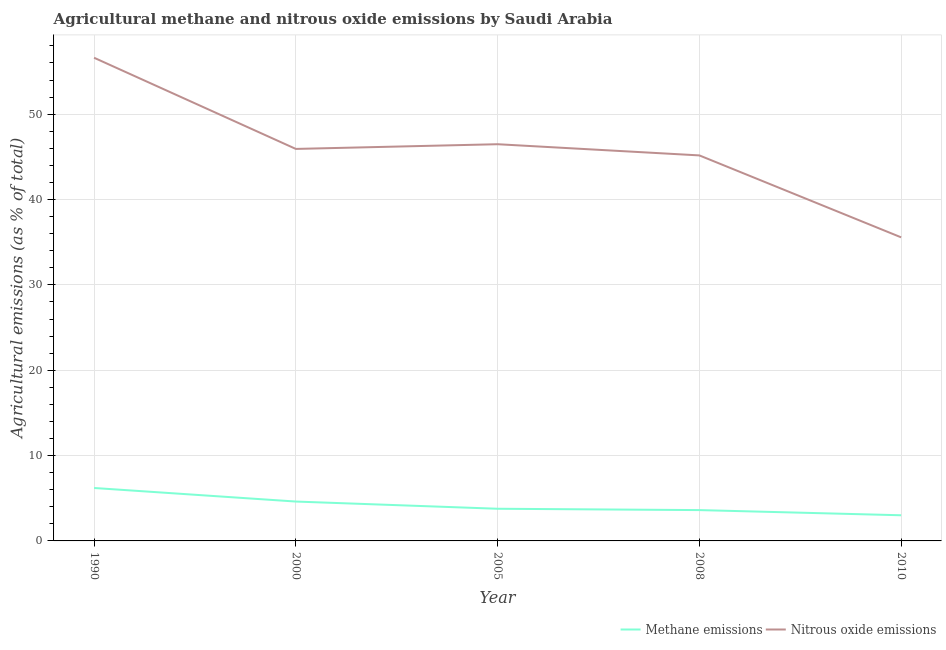What is the amount of nitrous oxide emissions in 2000?
Make the answer very short. 45.93. Across all years, what is the maximum amount of methane emissions?
Offer a terse response. 6.2. Across all years, what is the minimum amount of nitrous oxide emissions?
Give a very brief answer. 35.57. In which year was the amount of methane emissions maximum?
Provide a succinct answer. 1990. What is the total amount of nitrous oxide emissions in the graph?
Offer a very short reply. 229.76. What is the difference between the amount of nitrous oxide emissions in 2005 and that in 2010?
Your answer should be compact. 10.91. What is the difference between the amount of nitrous oxide emissions in 2008 and the amount of methane emissions in 2005?
Ensure brevity in your answer.  41.4. What is the average amount of nitrous oxide emissions per year?
Offer a terse response. 45.95. In the year 2005, what is the difference between the amount of nitrous oxide emissions and amount of methane emissions?
Provide a short and direct response. 42.71. What is the ratio of the amount of nitrous oxide emissions in 1990 to that in 2005?
Ensure brevity in your answer.  1.22. Is the difference between the amount of methane emissions in 2000 and 2008 greater than the difference between the amount of nitrous oxide emissions in 2000 and 2008?
Keep it short and to the point. Yes. What is the difference between the highest and the second highest amount of methane emissions?
Your answer should be very brief. 1.59. What is the difference between the highest and the lowest amount of methane emissions?
Your answer should be very brief. 3.2. Is the amount of nitrous oxide emissions strictly greater than the amount of methane emissions over the years?
Your answer should be very brief. Yes. Does the graph contain any zero values?
Ensure brevity in your answer.  No. Where does the legend appear in the graph?
Offer a very short reply. Bottom right. How many legend labels are there?
Provide a succinct answer. 2. What is the title of the graph?
Give a very brief answer. Agricultural methane and nitrous oxide emissions by Saudi Arabia. What is the label or title of the X-axis?
Your answer should be very brief. Year. What is the label or title of the Y-axis?
Offer a very short reply. Agricultural emissions (as % of total). What is the Agricultural emissions (as % of total) of Methane emissions in 1990?
Give a very brief answer. 6.2. What is the Agricultural emissions (as % of total) of Nitrous oxide emissions in 1990?
Your answer should be very brief. 56.61. What is the Agricultural emissions (as % of total) of Methane emissions in 2000?
Your answer should be very brief. 4.61. What is the Agricultural emissions (as % of total) in Nitrous oxide emissions in 2000?
Ensure brevity in your answer.  45.93. What is the Agricultural emissions (as % of total) in Methane emissions in 2005?
Your response must be concise. 3.77. What is the Agricultural emissions (as % of total) in Nitrous oxide emissions in 2005?
Your answer should be very brief. 46.48. What is the Agricultural emissions (as % of total) of Methane emissions in 2008?
Give a very brief answer. 3.61. What is the Agricultural emissions (as % of total) of Nitrous oxide emissions in 2008?
Give a very brief answer. 45.17. What is the Agricultural emissions (as % of total) in Methane emissions in 2010?
Make the answer very short. 3.01. What is the Agricultural emissions (as % of total) of Nitrous oxide emissions in 2010?
Your answer should be compact. 35.57. Across all years, what is the maximum Agricultural emissions (as % of total) of Methane emissions?
Your response must be concise. 6.2. Across all years, what is the maximum Agricultural emissions (as % of total) in Nitrous oxide emissions?
Your answer should be compact. 56.61. Across all years, what is the minimum Agricultural emissions (as % of total) of Methane emissions?
Offer a very short reply. 3.01. Across all years, what is the minimum Agricultural emissions (as % of total) of Nitrous oxide emissions?
Provide a succinct answer. 35.57. What is the total Agricultural emissions (as % of total) of Methane emissions in the graph?
Keep it short and to the point. 21.2. What is the total Agricultural emissions (as % of total) of Nitrous oxide emissions in the graph?
Provide a succinct answer. 229.76. What is the difference between the Agricultural emissions (as % of total) in Methane emissions in 1990 and that in 2000?
Your response must be concise. 1.59. What is the difference between the Agricultural emissions (as % of total) in Nitrous oxide emissions in 1990 and that in 2000?
Your response must be concise. 10.68. What is the difference between the Agricultural emissions (as % of total) of Methane emissions in 1990 and that in 2005?
Your answer should be compact. 2.43. What is the difference between the Agricultural emissions (as % of total) of Nitrous oxide emissions in 1990 and that in 2005?
Give a very brief answer. 10.13. What is the difference between the Agricultural emissions (as % of total) in Methane emissions in 1990 and that in 2008?
Provide a succinct answer. 2.59. What is the difference between the Agricultural emissions (as % of total) of Nitrous oxide emissions in 1990 and that in 2008?
Your answer should be very brief. 11.44. What is the difference between the Agricultural emissions (as % of total) in Methane emissions in 1990 and that in 2010?
Give a very brief answer. 3.2. What is the difference between the Agricultural emissions (as % of total) of Nitrous oxide emissions in 1990 and that in 2010?
Provide a succinct answer. 21.04. What is the difference between the Agricultural emissions (as % of total) in Methane emissions in 2000 and that in 2005?
Your answer should be very brief. 0.84. What is the difference between the Agricultural emissions (as % of total) of Nitrous oxide emissions in 2000 and that in 2005?
Give a very brief answer. -0.55. What is the difference between the Agricultural emissions (as % of total) in Nitrous oxide emissions in 2000 and that in 2008?
Provide a short and direct response. 0.76. What is the difference between the Agricultural emissions (as % of total) in Methane emissions in 2000 and that in 2010?
Make the answer very short. 1.61. What is the difference between the Agricultural emissions (as % of total) of Nitrous oxide emissions in 2000 and that in 2010?
Your response must be concise. 10.36. What is the difference between the Agricultural emissions (as % of total) of Methane emissions in 2005 and that in 2008?
Ensure brevity in your answer.  0.16. What is the difference between the Agricultural emissions (as % of total) in Nitrous oxide emissions in 2005 and that in 2008?
Provide a short and direct response. 1.31. What is the difference between the Agricultural emissions (as % of total) of Methane emissions in 2005 and that in 2010?
Provide a succinct answer. 0.76. What is the difference between the Agricultural emissions (as % of total) of Nitrous oxide emissions in 2005 and that in 2010?
Give a very brief answer. 10.91. What is the difference between the Agricultural emissions (as % of total) of Methane emissions in 2008 and that in 2010?
Your answer should be very brief. 0.61. What is the difference between the Agricultural emissions (as % of total) of Nitrous oxide emissions in 2008 and that in 2010?
Ensure brevity in your answer.  9.6. What is the difference between the Agricultural emissions (as % of total) in Methane emissions in 1990 and the Agricultural emissions (as % of total) in Nitrous oxide emissions in 2000?
Offer a terse response. -39.73. What is the difference between the Agricultural emissions (as % of total) in Methane emissions in 1990 and the Agricultural emissions (as % of total) in Nitrous oxide emissions in 2005?
Your answer should be compact. -40.28. What is the difference between the Agricultural emissions (as % of total) of Methane emissions in 1990 and the Agricultural emissions (as % of total) of Nitrous oxide emissions in 2008?
Your answer should be compact. -38.97. What is the difference between the Agricultural emissions (as % of total) in Methane emissions in 1990 and the Agricultural emissions (as % of total) in Nitrous oxide emissions in 2010?
Your answer should be compact. -29.37. What is the difference between the Agricultural emissions (as % of total) in Methane emissions in 2000 and the Agricultural emissions (as % of total) in Nitrous oxide emissions in 2005?
Offer a terse response. -41.87. What is the difference between the Agricultural emissions (as % of total) in Methane emissions in 2000 and the Agricultural emissions (as % of total) in Nitrous oxide emissions in 2008?
Provide a short and direct response. -40.56. What is the difference between the Agricultural emissions (as % of total) in Methane emissions in 2000 and the Agricultural emissions (as % of total) in Nitrous oxide emissions in 2010?
Ensure brevity in your answer.  -30.95. What is the difference between the Agricultural emissions (as % of total) in Methane emissions in 2005 and the Agricultural emissions (as % of total) in Nitrous oxide emissions in 2008?
Offer a very short reply. -41.4. What is the difference between the Agricultural emissions (as % of total) of Methane emissions in 2005 and the Agricultural emissions (as % of total) of Nitrous oxide emissions in 2010?
Your answer should be very brief. -31.8. What is the difference between the Agricultural emissions (as % of total) of Methane emissions in 2008 and the Agricultural emissions (as % of total) of Nitrous oxide emissions in 2010?
Give a very brief answer. -31.96. What is the average Agricultural emissions (as % of total) in Methane emissions per year?
Offer a terse response. 4.24. What is the average Agricultural emissions (as % of total) of Nitrous oxide emissions per year?
Give a very brief answer. 45.95. In the year 1990, what is the difference between the Agricultural emissions (as % of total) in Methane emissions and Agricultural emissions (as % of total) in Nitrous oxide emissions?
Make the answer very short. -50.41. In the year 2000, what is the difference between the Agricultural emissions (as % of total) in Methane emissions and Agricultural emissions (as % of total) in Nitrous oxide emissions?
Give a very brief answer. -41.32. In the year 2005, what is the difference between the Agricultural emissions (as % of total) of Methane emissions and Agricultural emissions (as % of total) of Nitrous oxide emissions?
Make the answer very short. -42.71. In the year 2008, what is the difference between the Agricultural emissions (as % of total) in Methane emissions and Agricultural emissions (as % of total) in Nitrous oxide emissions?
Offer a terse response. -41.56. In the year 2010, what is the difference between the Agricultural emissions (as % of total) of Methane emissions and Agricultural emissions (as % of total) of Nitrous oxide emissions?
Provide a succinct answer. -32.56. What is the ratio of the Agricultural emissions (as % of total) of Methane emissions in 1990 to that in 2000?
Make the answer very short. 1.34. What is the ratio of the Agricultural emissions (as % of total) of Nitrous oxide emissions in 1990 to that in 2000?
Offer a very short reply. 1.23. What is the ratio of the Agricultural emissions (as % of total) in Methane emissions in 1990 to that in 2005?
Provide a short and direct response. 1.65. What is the ratio of the Agricultural emissions (as % of total) of Nitrous oxide emissions in 1990 to that in 2005?
Offer a very short reply. 1.22. What is the ratio of the Agricultural emissions (as % of total) of Methane emissions in 1990 to that in 2008?
Your response must be concise. 1.72. What is the ratio of the Agricultural emissions (as % of total) in Nitrous oxide emissions in 1990 to that in 2008?
Keep it short and to the point. 1.25. What is the ratio of the Agricultural emissions (as % of total) in Methane emissions in 1990 to that in 2010?
Provide a short and direct response. 2.06. What is the ratio of the Agricultural emissions (as % of total) of Nitrous oxide emissions in 1990 to that in 2010?
Offer a very short reply. 1.59. What is the ratio of the Agricultural emissions (as % of total) in Methane emissions in 2000 to that in 2005?
Offer a very short reply. 1.22. What is the ratio of the Agricultural emissions (as % of total) of Methane emissions in 2000 to that in 2008?
Make the answer very short. 1.28. What is the ratio of the Agricultural emissions (as % of total) of Nitrous oxide emissions in 2000 to that in 2008?
Offer a very short reply. 1.02. What is the ratio of the Agricultural emissions (as % of total) of Methane emissions in 2000 to that in 2010?
Your answer should be very brief. 1.54. What is the ratio of the Agricultural emissions (as % of total) of Nitrous oxide emissions in 2000 to that in 2010?
Offer a terse response. 1.29. What is the ratio of the Agricultural emissions (as % of total) in Methane emissions in 2005 to that in 2008?
Provide a short and direct response. 1.04. What is the ratio of the Agricultural emissions (as % of total) in Methane emissions in 2005 to that in 2010?
Provide a succinct answer. 1.25. What is the ratio of the Agricultural emissions (as % of total) in Nitrous oxide emissions in 2005 to that in 2010?
Keep it short and to the point. 1.31. What is the ratio of the Agricultural emissions (as % of total) in Methane emissions in 2008 to that in 2010?
Offer a very short reply. 1.2. What is the ratio of the Agricultural emissions (as % of total) in Nitrous oxide emissions in 2008 to that in 2010?
Offer a terse response. 1.27. What is the difference between the highest and the second highest Agricultural emissions (as % of total) in Methane emissions?
Your answer should be compact. 1.59. What is the difference between the highest and the second highest Agricultural emissions (as % of total) of Nitrous oxide emissions?
Ensure brevity in your answer.  10.13. What is the difference between the highest and the lowest Agricultural emissions (as % of total) of Methane emissions?
Provide a succinct answer. 3.2. What is the difference between the highest and the lowest Agricultural emissions (as % of total) in Nitrous oxide emissions?
Your response must be concise. 21.04. 